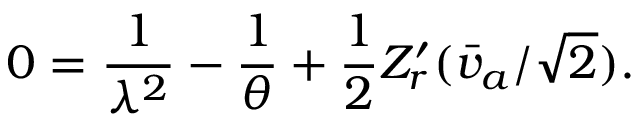Convert formula to latex. <formula><loc_0><loc_0><loc_500><loc_500>0 = { \frac { 1 } { \lambda ^ { 2 } } } - { \frac { 1 } { \theta } } + { \frac { 1 } { 2 } } Z _ { r } ^ { \prime } ( \bar { v } _ { a } / \sqrt { 2 } ) .</formula> 